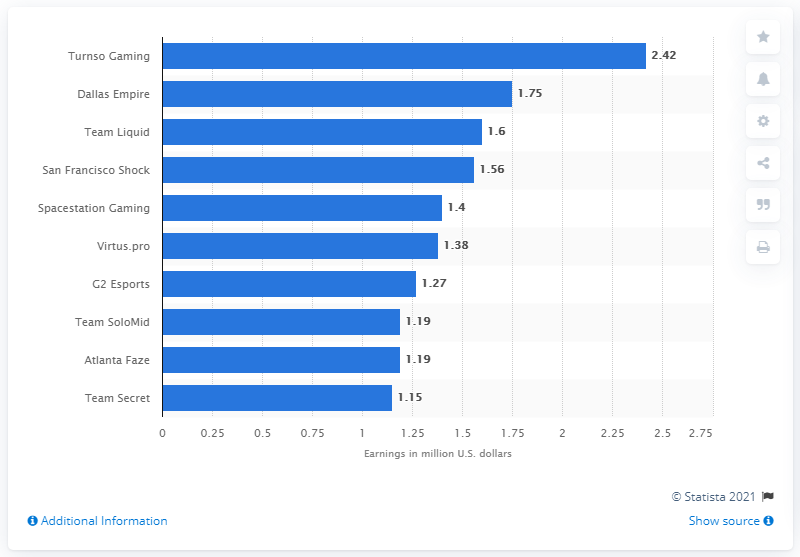Draw attention to some important aspects in this diagram. Turnso Gaming earned $2.42 million in the U.S. in 2020. Turnso Gaming was the most successful eSports team of 2020. 